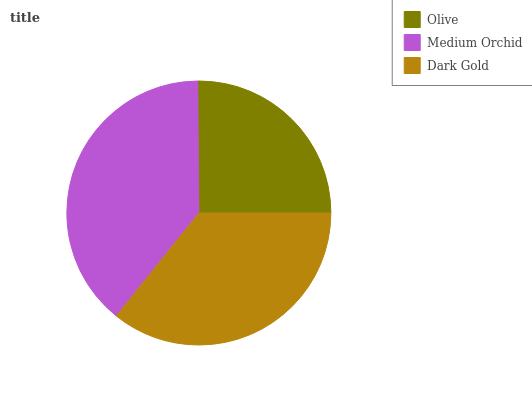Is Olive the minimum?
Answer yes or no. Yes. Is Medium Orchid the maximum?
Answer yes or no. Yes. Is Dark Gold the minimum?
Answer yes or no. No. Is Dark Gold the maximum?
Answer yes or no. No. Is Medium Orchid greater than Dark Gold?
Answer yes or no. Yes. Is Dark Gold less than Medium Orchid?
Answer yes or no. Yes. Is Dark Gold greater than Medium Orchid?
Answer yes or no. No. Is Medium Orchid less than Dark Gold?
Answer yes or no. No. Is Dark Gold the high median?
Answer yes or no. Yes. Is Dark Gold the low median?
Answer yes or no. Yes. Is Olive the high median?
Answer yes or no. No. Is Olive the low median?
Answer yes or no. No. 